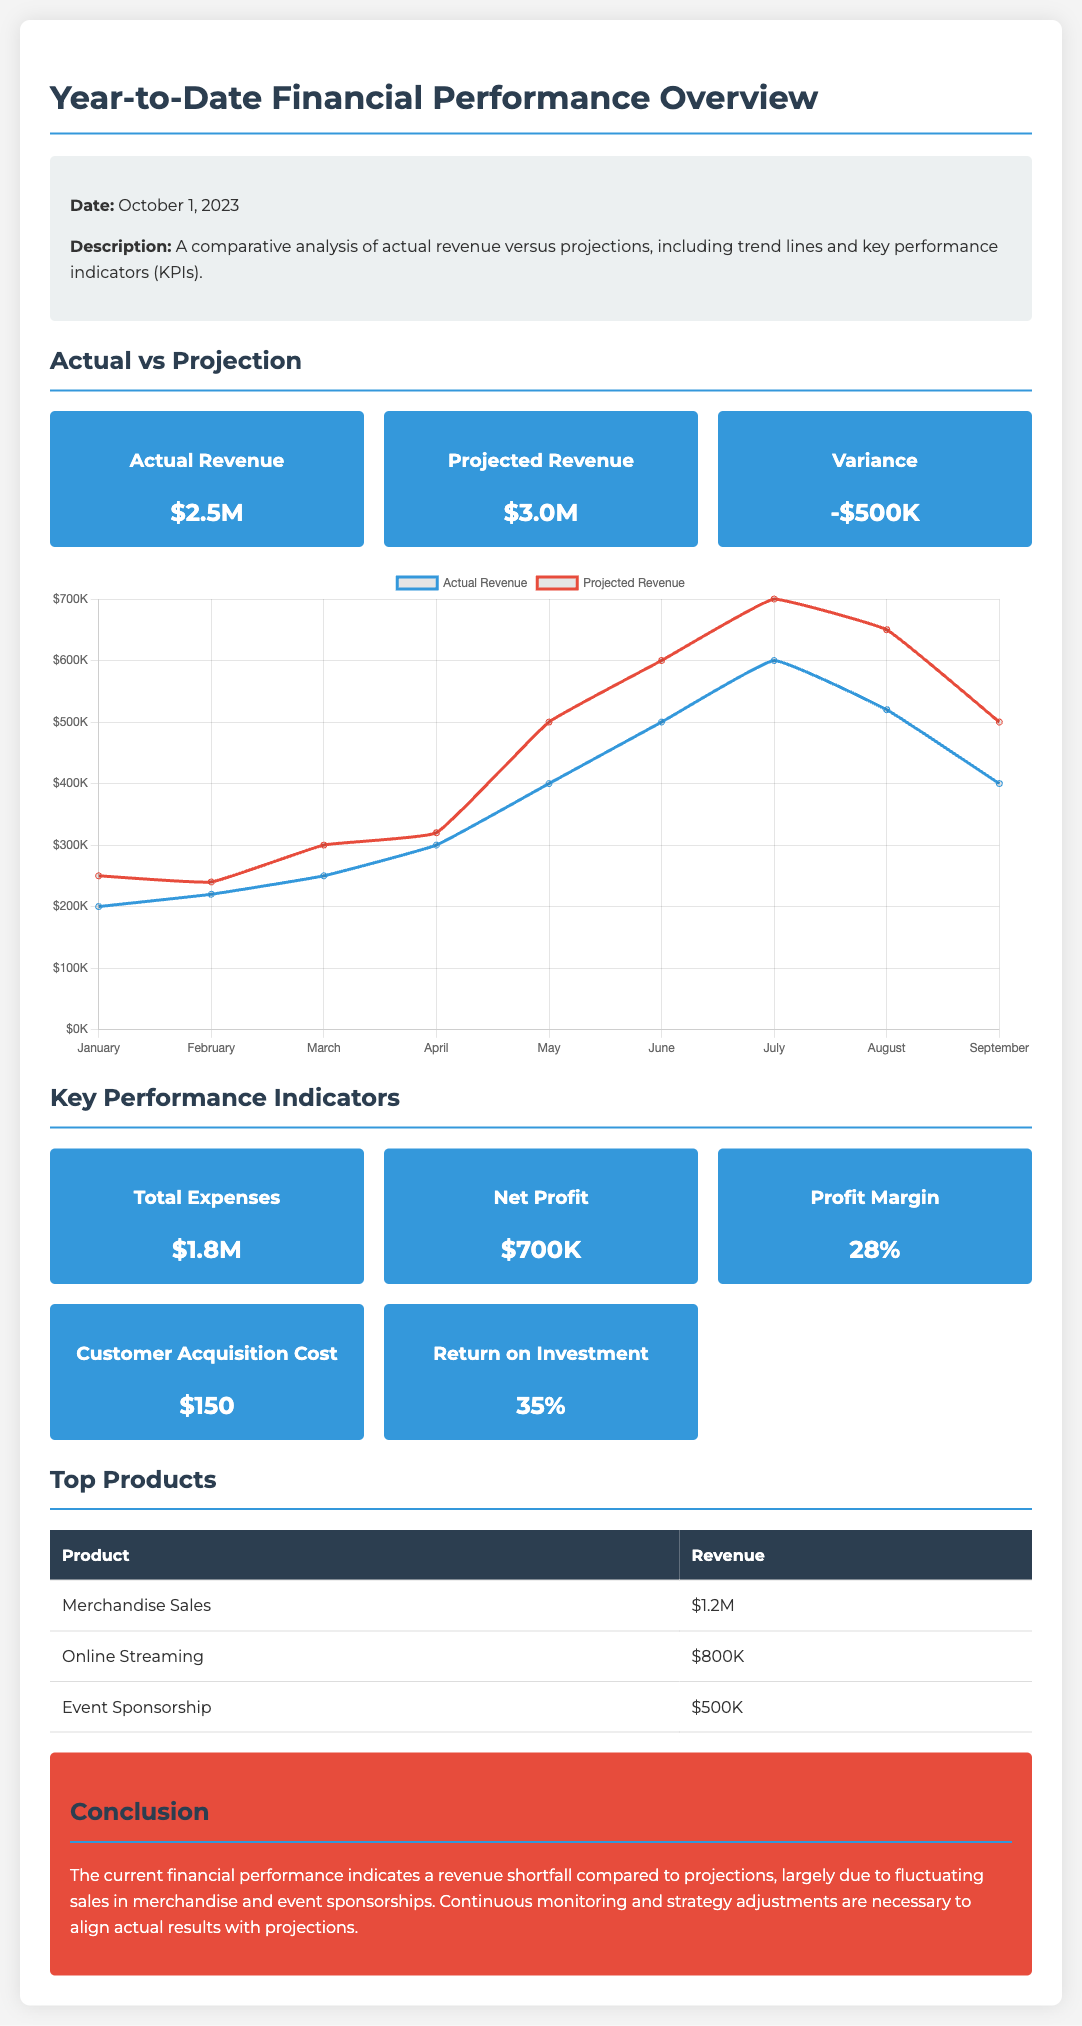What is the actual revenue? The actual revenue reported in the document is $2.5M.
Answer: $2.5M What is the projected revenue? The projected revenue noted in the report is $3.0M.
Answer: $3.0M What is the variance in revenue? The variance is calculated by subtracting actual revenue from projected revenue, resulting in -$500K.
Answer: -$500K What is the profit margin? The profit margin listed in the KPIs is shown as 28%.
Answer: 28% What are the total expenses? The total expenses mentioned in the report amount to $1.8M.
Answer: $1.8M What was the revenue from merchandise sales? The revenue from merchandise sales is displayed as $1.2M in the table of top products.
Answer: $1.2M What is the customer acquisition cost? The customer acquisition cost mentioned in the document is $150.
Answer: $150 What indicator shows a revenue trend? The chart titled "Actual vs Projection" shows the revenue trend with lines for actual and projected revenues.
Answer: Chart What is the date of the financial performance overview? The date provided in the document is October 1, 2023.
Answer: October 1, 2023 What does the conclusion suggest about revenue? The conclusion indicates a revenue shortfall compared to projections.
Answer: Revenue shortfall 